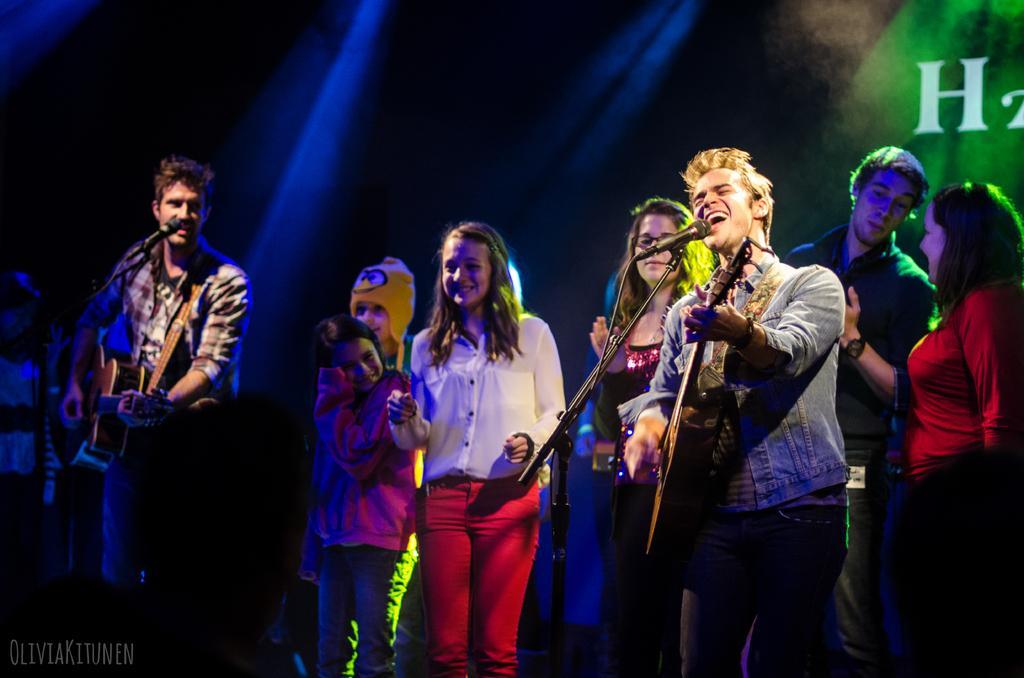In one or two sentences, can you explain what this image depicts? This picture is taken in the dark where we can see these two people are holding guitars in their hands and there is a mic to stand in front of them. Also, we can see these people are standing on the stage. In the background, we can see the show lights. Here we can see some watermark on the bottom left side of the image. 